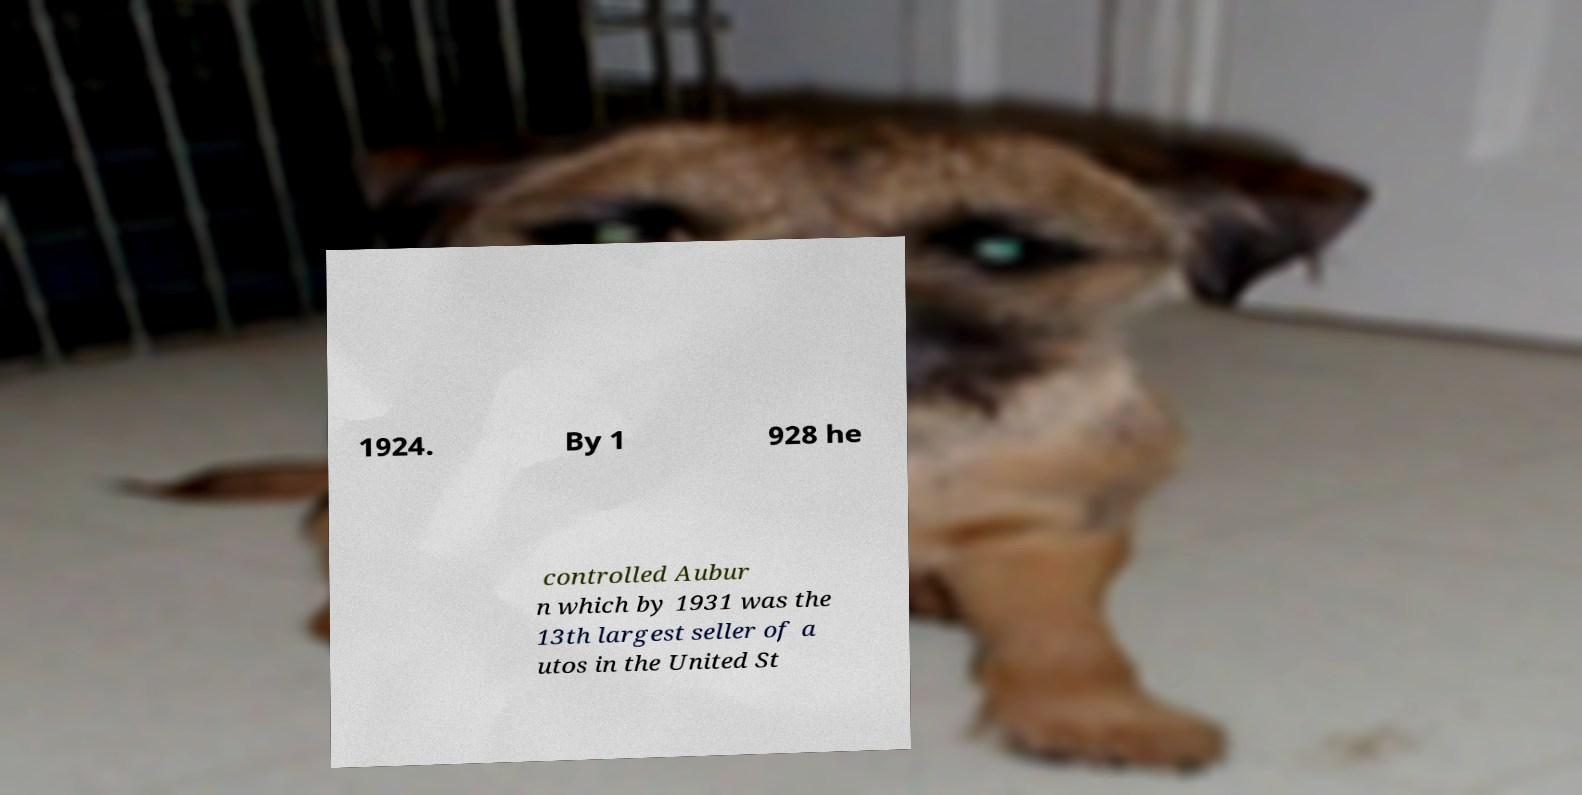Please identify and transcribe the text found in this image. 1924. By 1 928 he controlled Aubur n which by 1931 was the 13th largest seller of a utos in the United St 